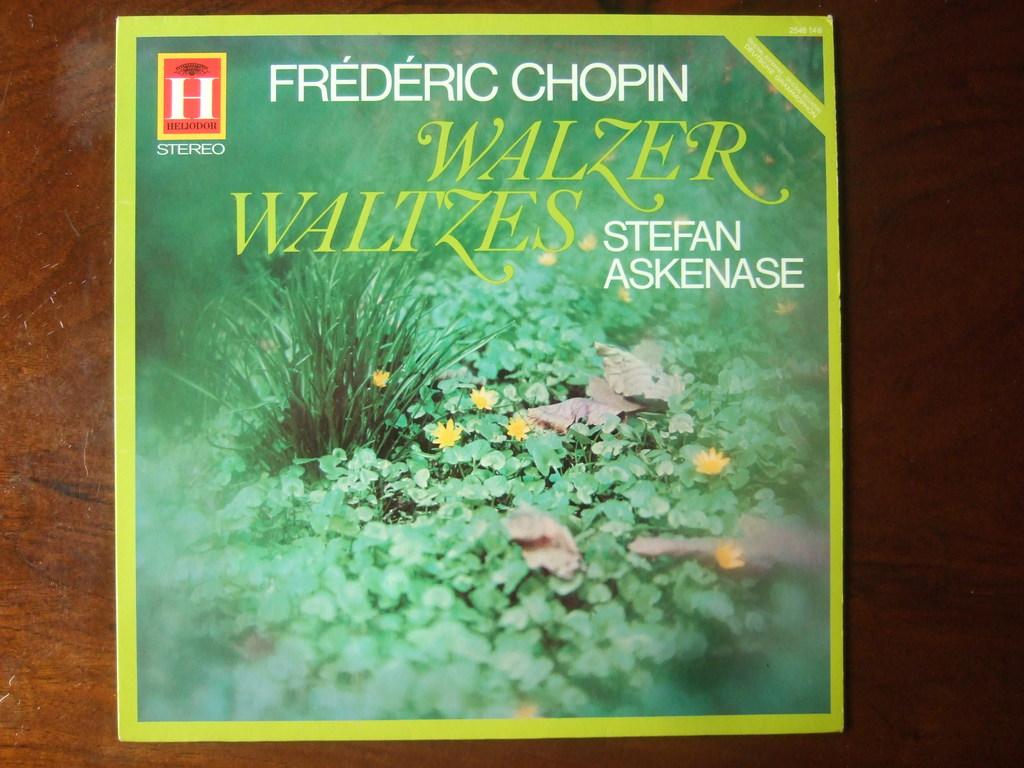Who is the author?
Make the answer very short. Stefan askenase. 